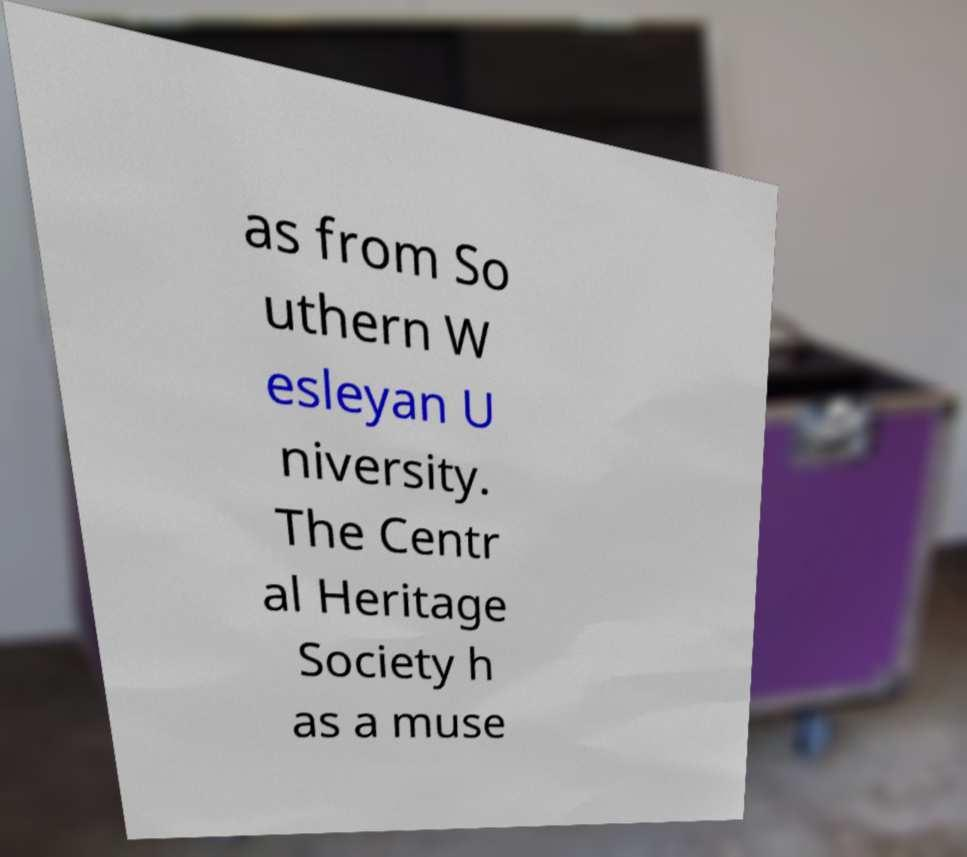Please read and relay the text visible in this image. What does it say? as from So uthern W esleyan U niversity. The Centr al Heritage Society h as a muse 